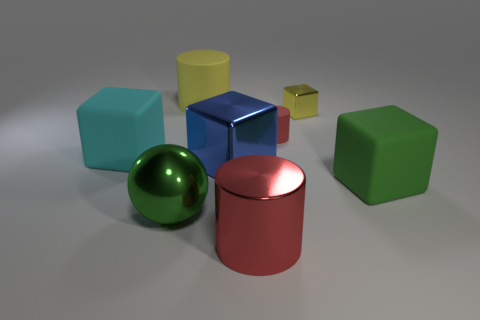Add 1 yellow metal cubes. How many objects exist? 9 Subtract all spheres. How many objects are left? 7 Subtract 0 gray blocks. How many objects are left? 8 Subtract all yellow metal objects. Subtract all large green rubber objects. How many objects are left? 6 Add 8 large green objects. How many large green objects are left? 10 Add 2 large blue shiny things. How many large blue shiny things exist? 3 